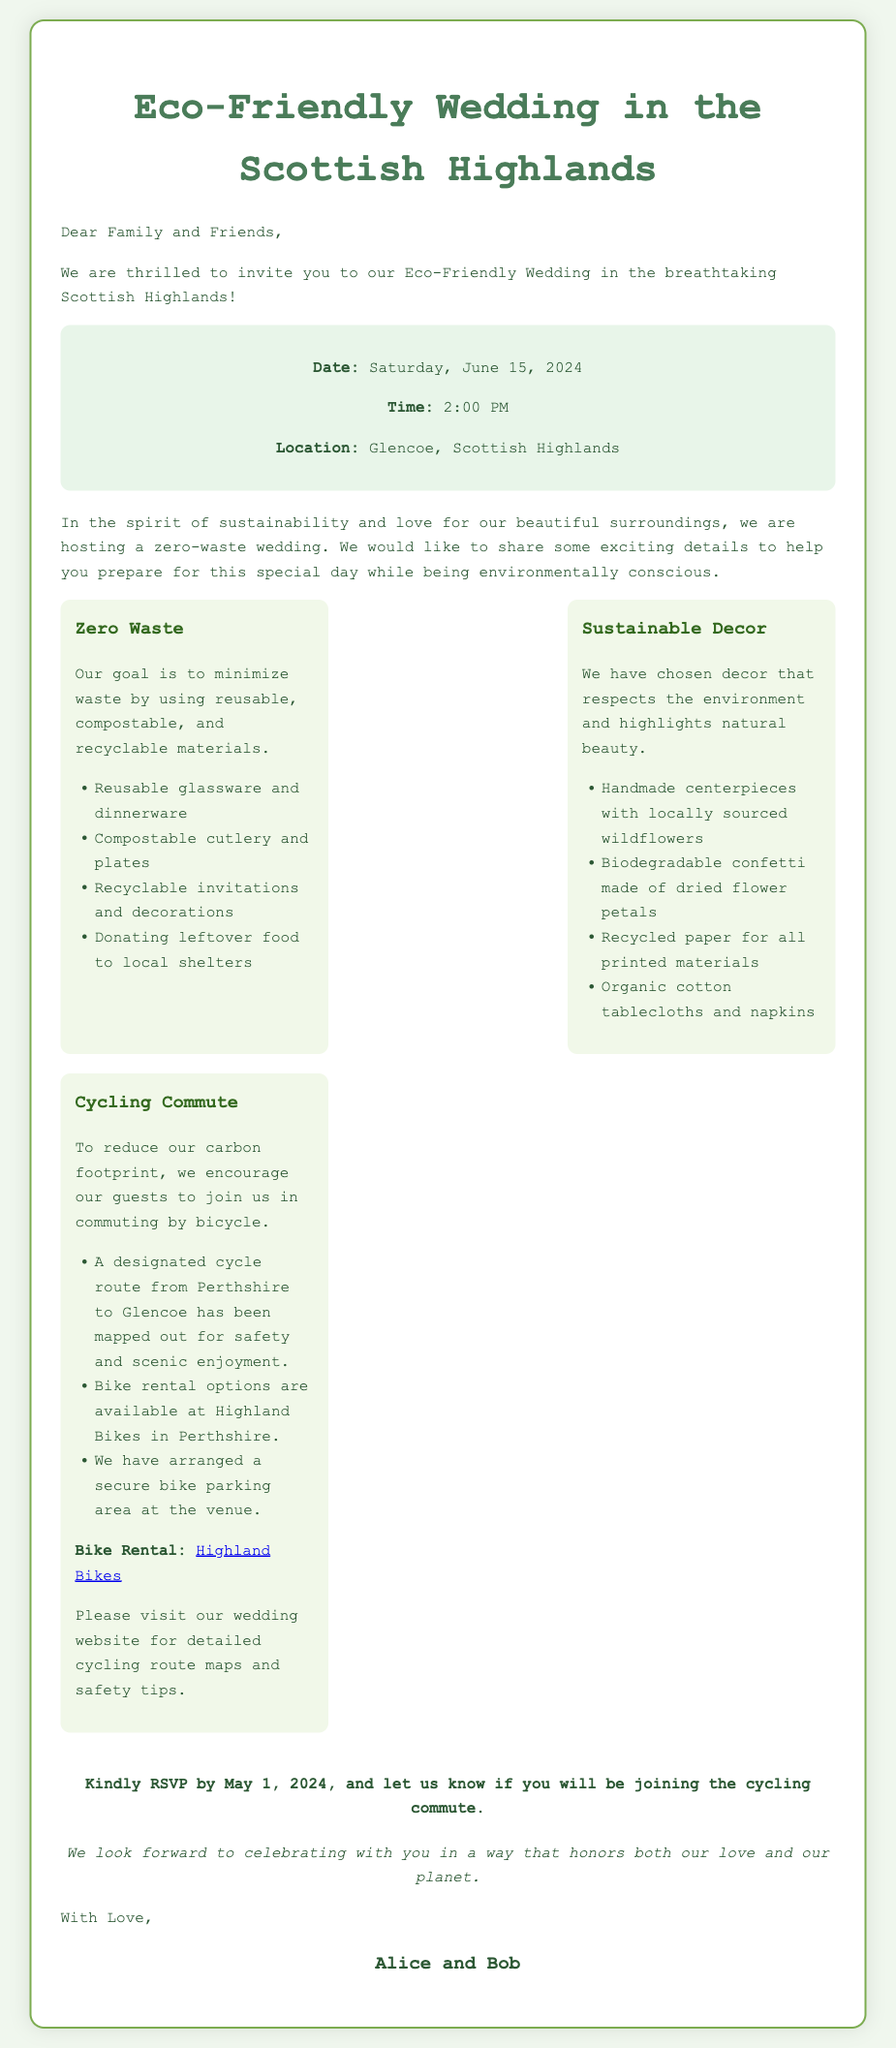What is the wedding date? The wedding date is explicitly mentioned in the document as June 15, 2024.
Answer: June 15, 2024 What time does the wedding start? The starting time of the wedding is provided in the document as 2:00 PM.
Answer: 2:00 PM Where is the wedding location? The wedding location is specified in the document as Glencoe, Scottish Highlands.
Answer: Glencoe, Scottish Highlands What type of materials are being used for the cutlery? The document mentions that compostable cutlery is part of the zero-waste wedding materials.
Answer: Compostable What is one option for cycling guests? The document states that there are bike rental options available at Highland Bikes.
Answer: Highland Bikes Why is cycling encouraged for guests? The document explains that cycling is encouraged to reduce the carbon footprint.
Answer: To reduce carbon footprint What date is the RSVP deadline? The RSVP deadline is clearly indicated in the document as May 1, 2024.
Answer: May 1, 2024 What is a unique feature of the wedding decorations? The document mentions handmade centerpieces with locally sourced wildflowers as a unique decoration feature.
Answer: Handmade centerpieces What should guests do if they want to bike? The document suggests visiting the wedding website for cycling route maps and safety tips for biking guests.
Answer: Visit the wedding website 